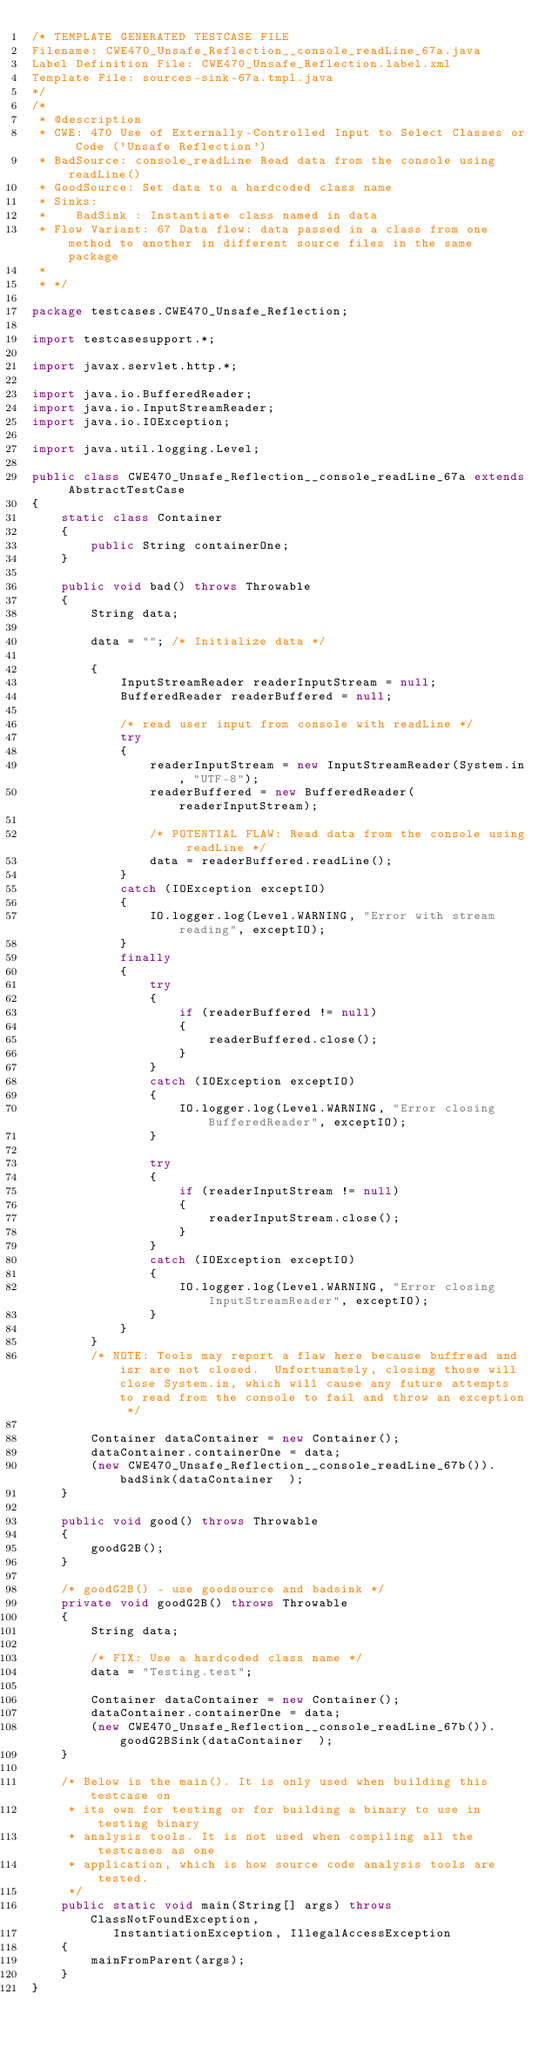<code> <loc_0><loc_0><loc_500><loc_500><_Java_>/* TEMPLATE GENERATED TESTCASE FILE
Filename: CWE470_Unsafe_Reflection__console_readLine_67a.java
Label Definition File: CWE470_Unsafe_Reflection.label.xml
Template File: sources-sink-67a.tmpl.java
*/
/*
 * @description
 * CWE: 470 Use of Externally-Controlled Input to Select Classes or Code ('Unsafe Reflection')
 * BadSource: console_readLine Read data from the console using readLine()
 * GoodSource: Set data to a hardcoded class name
 * Sinks:
 *    BadSink : Instantiate class named in data
 * Flow Variant: 67 Data flow: data passed in a class from one method to another in different source files in the same package
 *
 * */

package testcases.CWE470_Unsafe_Reflection;

import testcasesupport.*;

import javax.servlet.http.*;

import java.io.BufferedReader;
import java.io.InputStreamReader;
import java.io.IOException;

import java.util.logging.Level;

public class CWE470_Unsafe_Reflection__console_readLine_67a extends AbstractTestCase
{
    static class Container
    {
        public String containerOne;
    }

    public void bad() throws Throwable
    {
        String data;

        data = ""; /* Initialize data */

        {
            InputStreamReader readerInputStream = null;
            BufferedReader readerBuffered = null;

            /* read user input from console with readLine */
            try
            {
                readerInputStream = new InputStreamReader(System.in, "UTF-8");
                readerBuffered = new BufferedReader(readerInputStream);

                /* POTENTIAL FLAW: Read data from the console using readLine */
                data = readerBuffered.readLine();
            }
            catch (IOException exceptIO)
            {
                IO.logger.log(Level.WARNING, "Error with stream reading", exceptIO);
            }
            finally
            {
                try
                {
                    if (readerBuffered != null)
                    {
                        readerBuffered.close();
                    }
                }
                catch (IOException exceptIO)
                {
                    IO.logger.log(Level.WARNING, "Error closing BufferedReader", exceptIO);
                }

                try
                {
                    if (readerInputStream != null)
                    {
                        readerInputStream.close();
                    }
                }
                catch (IOException exceptIO)
                {
                    IO.logger.log(Level.WARNING, "Error closing InputStreamReader", exceptIO);
                }
            }
        }
        /* NOTE: Tools may report a flaw here because buffread and isr are not closed.  Unfortunately, closing those will close System.in, which will cause any future attempts to read from the console to fail and throw an exception */

        Container dataContainer = new Container();
        dataContainer.containerOne = data;
        (new CWE470_Unsafe_Reflection__console_readLine_67b()).badSink(dataContainer  );
    }

    public void good() throws Throwable
    {
        goodG2B();
    }

    /* goodG2B() - use goodsource and badsink */
    private void goodG2B() throws Throwable
    {
        String data;

        /* FIX: Use a hardcoded class name */
        data = "Testing.test";

        Container dataContainer = new Container();
        dataContainer.containerOne = data;
        (new CWE470_Unsafe_Reflection__console_readLine_67b()).goodG2BSink(dataContainer  );
    }

    /* Below is the main(). It is only used when building this testcase on
     * its own for testing or for building a binary to use in testing binary
     * analysis tools. It is not used when compiling all the testcases as one
     * application, which is how source code analysis tools are tested.
     */
    public static void main(String[] args) throws ClassNotFoundException,
           InstantiationException, IllegalAccessException
    {
        mainFromParent(args);
    }
}
</code> 